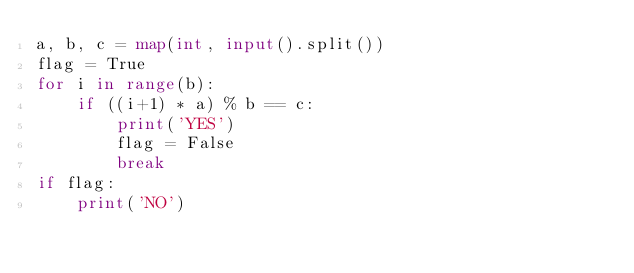<code> <loc_0><loc_0><loc_500><loc_500><_Python_>a, b, c = map(int, input().split())
flag = True
for i in range(b):
    if ((i+1) * a) % b == c:
        print('YES')
        flag = False
        break
if flag:
    print('NO')</code> 